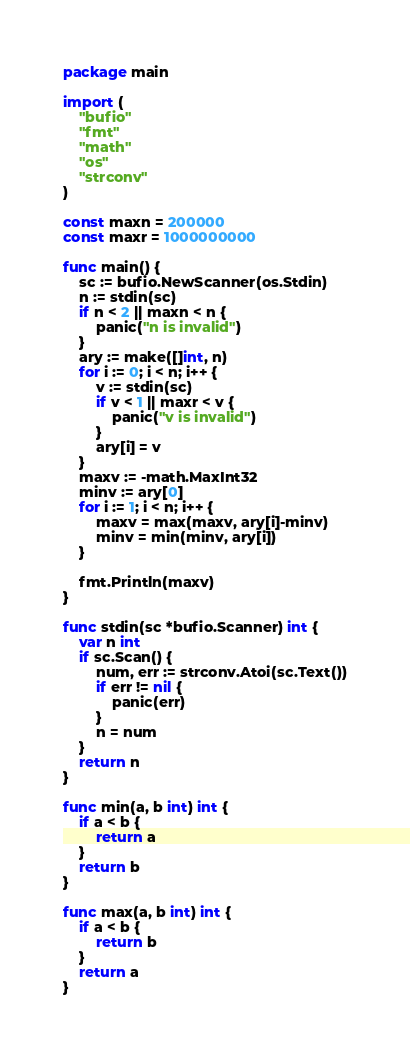<code> <loc_0><loc_0><loc_500><loc_500><_Go_>package main

import (
	"bufio"
	"fmt"
	"math"
	"os"
	"strconv"
)

const maxn = 200000
const maxr = 1000000000

func main() {
	sc := bufio.NewScanner(os.Stdin)
	n := stdin(sc)
	if n < 2 || maxn < n {
		panic("n is invalid")
	}
	ary := make([]int, n)
	for i := 0; i < n; i++ {
		v := stdin(sc)
		if v < 1 || maxr < v {
			panic("v is invalid")
		}
		ary[i] = v
	}
	maxv := -math.MaxInt32
	minv := ary[0]
	for i := 1; i < n; i++ {
		maxv = max(maxv, ary[i]-minv)
		minv = min(minv, ary[i])
	}

	fmt.Println(maxv)
}

func stdin(sc *bufio.Scanner) int {
	var n int
	if sc.Scan() {
		num, err := strconv.Atoi(sc.Text())
		if err != nil {
			panic(err)
		}
		n = num
	}
	return n
}

func min(a, b int) int {
	if a < b {
		return a
	}
	return b
}

func max(a, b int) int {
	if a < b {
		return b
	}
	return a
}

</code> 